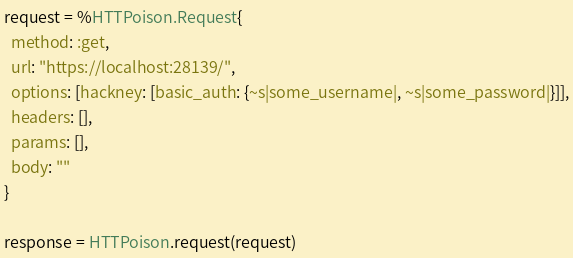Convert code to text. <code><loc_0><loc_0><loc_500><loc_500><_Elixir_>request = %HTTPoison.Request{
  method: :get,
  url: "https://localhost:28139/",
  options: [hackney: [basic_auth: {~s|some_username|, ~s|some_password|}]],
  headers: [],
  params: [],
  body: ""
}

response = HTTPoison.request(request)
</code> 